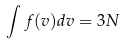Convert formula to latex. <formula><loc_0><loc_0><loc_500><loc_500>\int f ( v ) d v = 3 N</formula> 